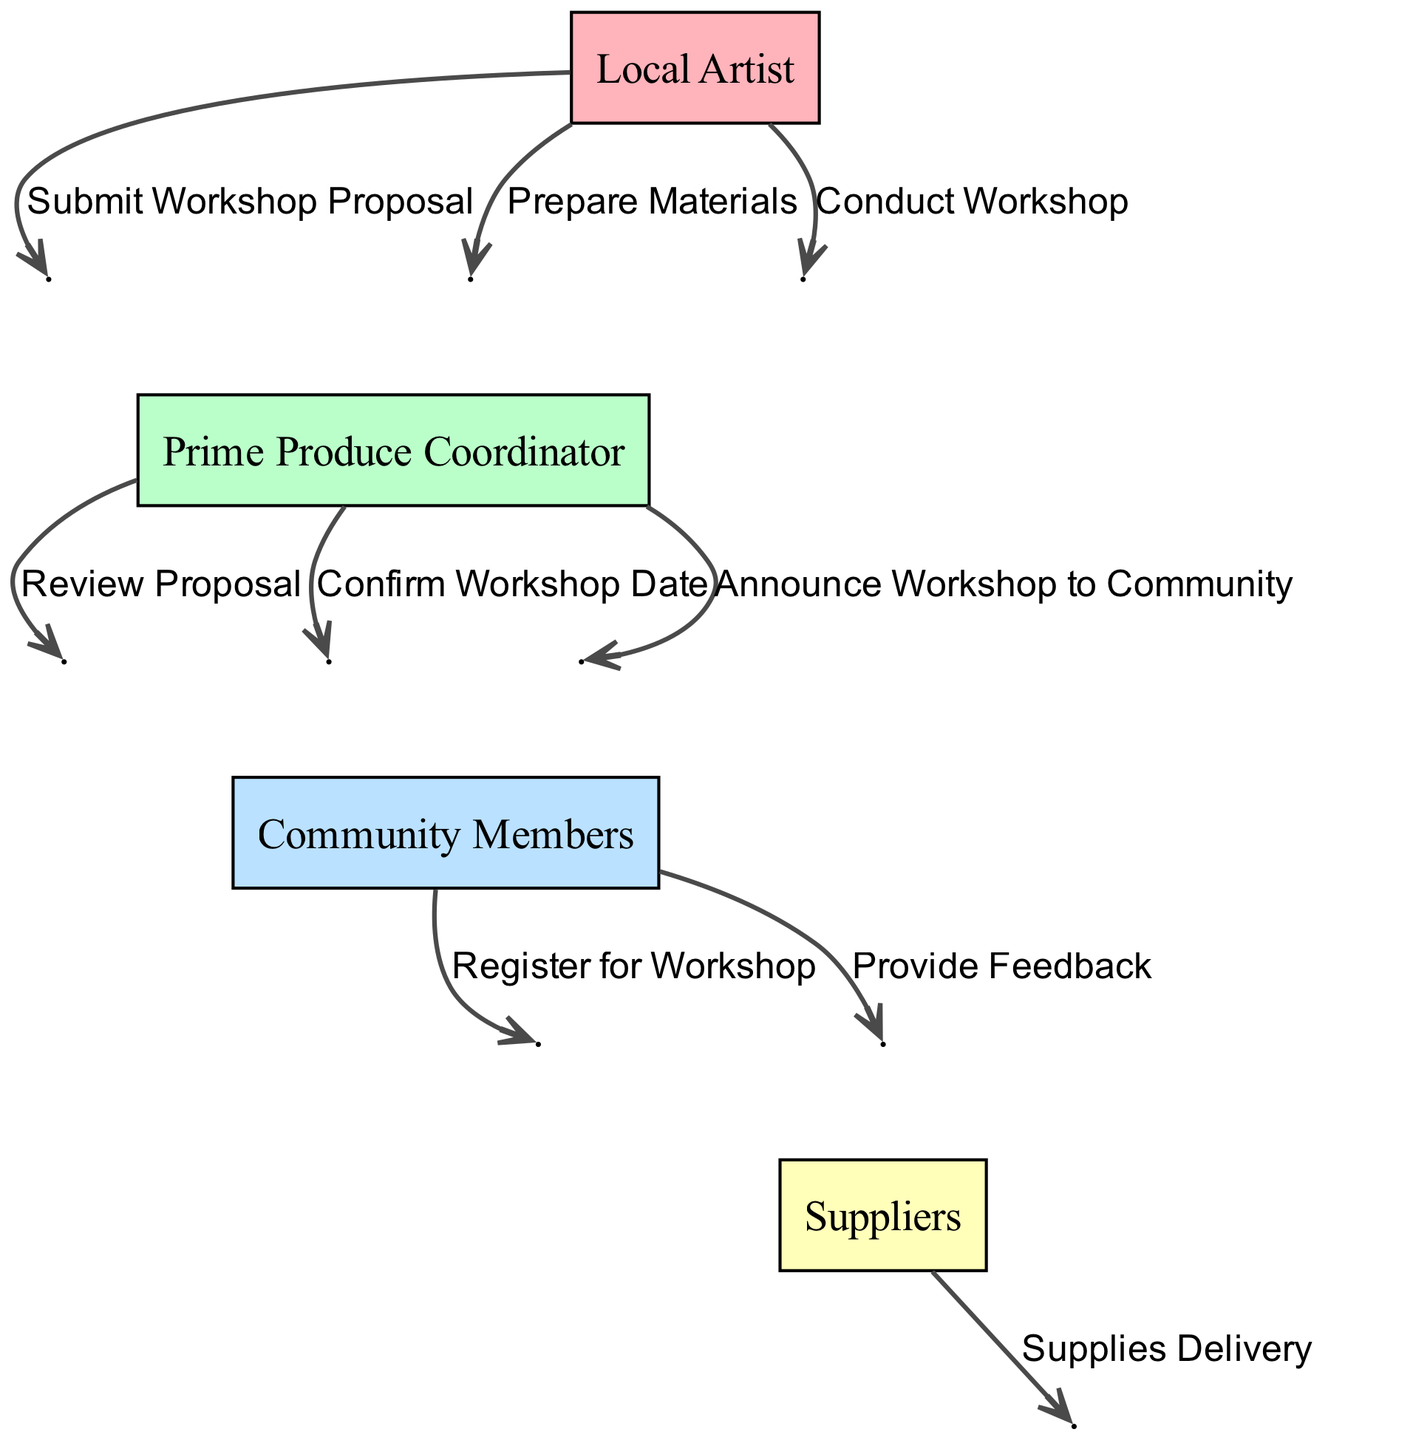What is the first action performed in the sequence? The first action in the diagram is initiated by the Local Artist when they submit the workshop proposal.
Answer: Submit Workshop Proposal How many actors are involved in the sequence? There are four actors participating in the sequence diagram: Local Artist, Prime Produce Coordinator, Community Members, and Suppliers.
Answer: Four Who confirms the workshop date? The workshop date is confirmed by the Prime Produce Coordinator.
Answer: Prime Produce Coordinator What action follows the announcement of the workshop? After announcing the workshop to the community, the next action is for community members to register for the workshop.
Answer: Register for Workshop Which actor is responsible for delivering supplies? The actor responsible for supplying the materials for the workshop is the Suppliers.
Answer: Suppliers What is the last action that occurs in the sequence? The last action recorded in the sequence is when community members provide feedback after the workshop.
Answer: Provide Feedback How many actions are taken by the Local Artist? The Local Artist engages in three actions: submitting the proposal, preparing materials, and conducting the workshop.
Answer: Three What action leads to the Community Members registering? The announcement of the workshop to the community leads to community members registering for the workshop.
Answer: Announce Workshop to Community Which action directly proceeds the review of the proposal? After the review of the proposal, the Prime Produce Coordinator confirms the workshop date.
Answer: Confirm Workshop Date 